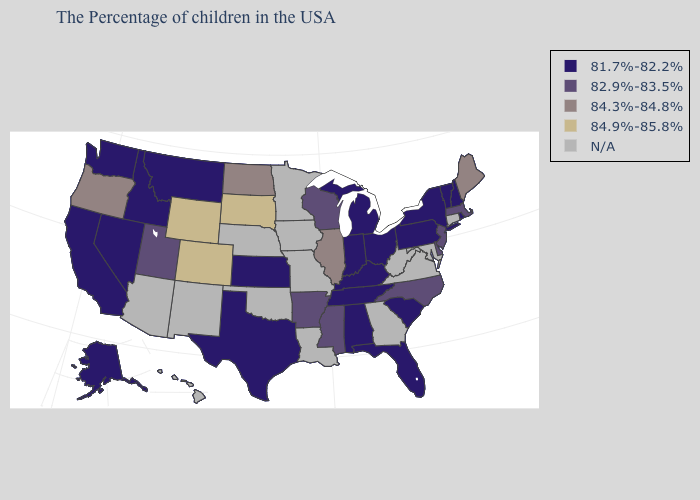Does the first symbol in the legend represent the smallest category?
Be succinct. Yes. What is the value of Kentucky?
Quick response, please. 81.7%-82.2%. Among the states that border Montana , which have the lowest value?
Be succinct. Idaho. Name the states that have a value in the range 82.9%-83.5%?
Short answer required. Massachusetts, New Jersey, Delaware, North Carolina, Wisconsin, Mississippi, Arkansas, Utah. What is the lowest value in states that border Montana?
Give a very brief answer. 81.7%-82.2%. Which states have the lowest value in the South?
Concise answer only. South Carolina, Florida, Kentucky, Alabama, Tennessee, Texas. Among the states that border Alabama , does Mississippi have the highest value?
Keep it brief. Yes. What is the value of Oklahoma?
Concise answer only. N/A. What is the highest value in the USA?
Be succinct. 84.9%-85.8%. Does Idaho have the highest value in the USA?
Write a very short answer. No. Which states have the lowest value in the West?
Answer briefly. Montana, Idaho, Nevada, California, Washington, Alaska. Among the states that border Rhode Island , which have the highest value?
Concise answer only. Massachusetts. Name the states that have a value in the range 84.3%-84.8%?
Give a very brief answer. Maine, Illinois, North Dakota, Oregon. What is the lowest value in the USA?
Quick response, please. 81.7%-82.2%. 